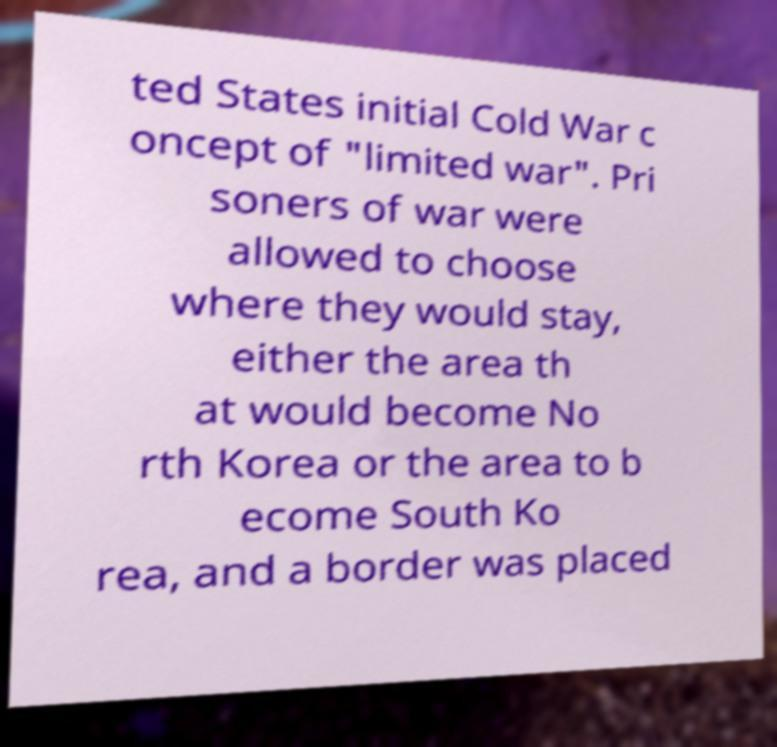What messages or text are displayed in this image? I need them in a readable, typed format. ted States initial Cold War c oncept of "limited war". Pri soners of war were allowed to choose where they would stay, either the area th at would become No rth Korea or the area to b ecome South Ko rea, and a border was placed 